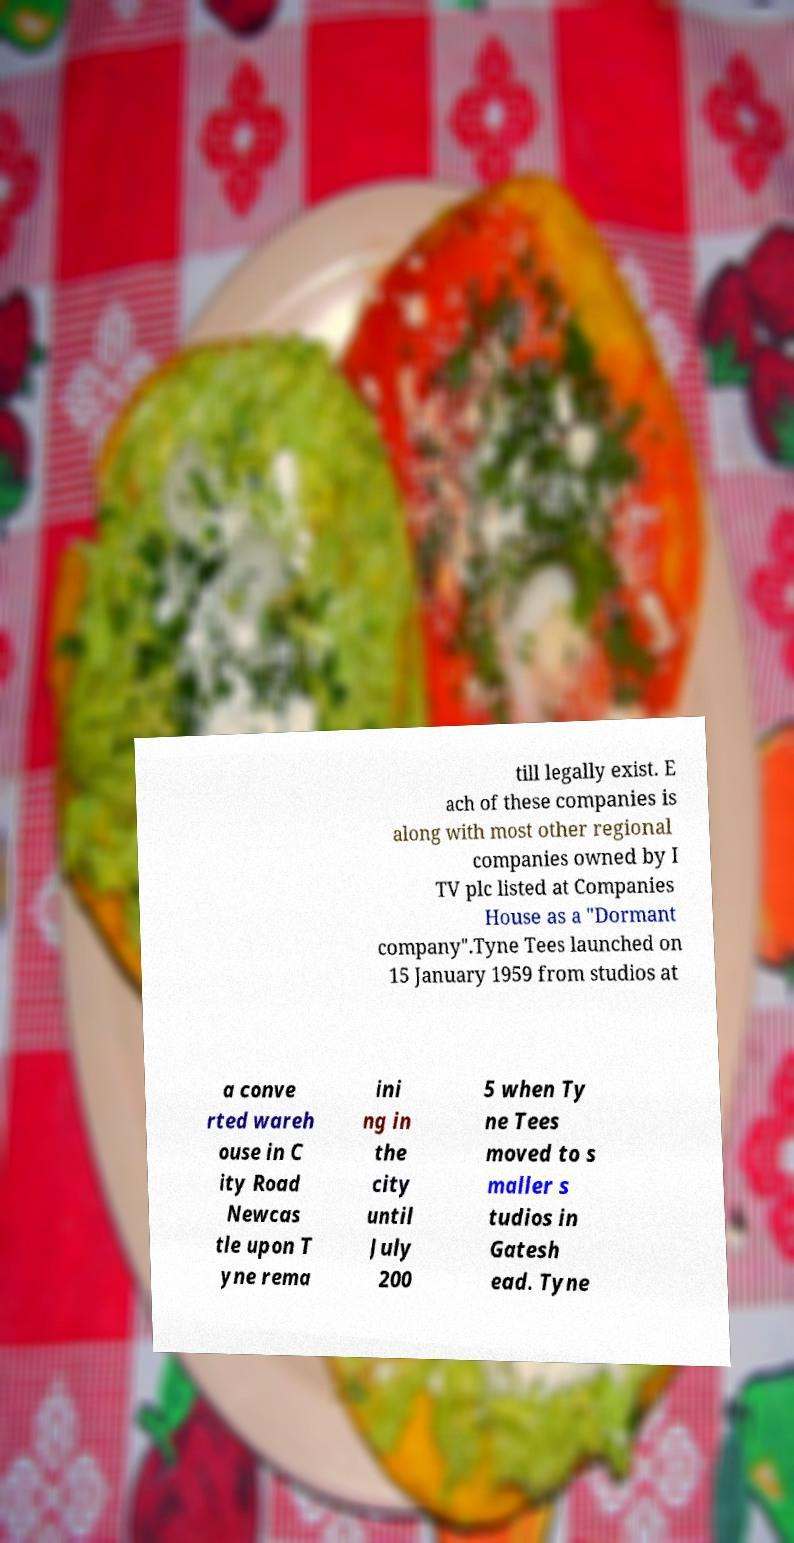Can you accurately transcribe the text from the provided image for me? till legally exist. E ach of these companies is along with most other regional companies owned by I TV plc listed at Companies House as a "Dormant company".Tyne Tees launched on 15 January 1959 from studios at a conve rted wareh ouse in C ity Road Newcas tle upon T yne rema ini ng in the city until July 200 5 when Ty ne Tees moved to s maller s tudios in Gatesh ead. Tyne 